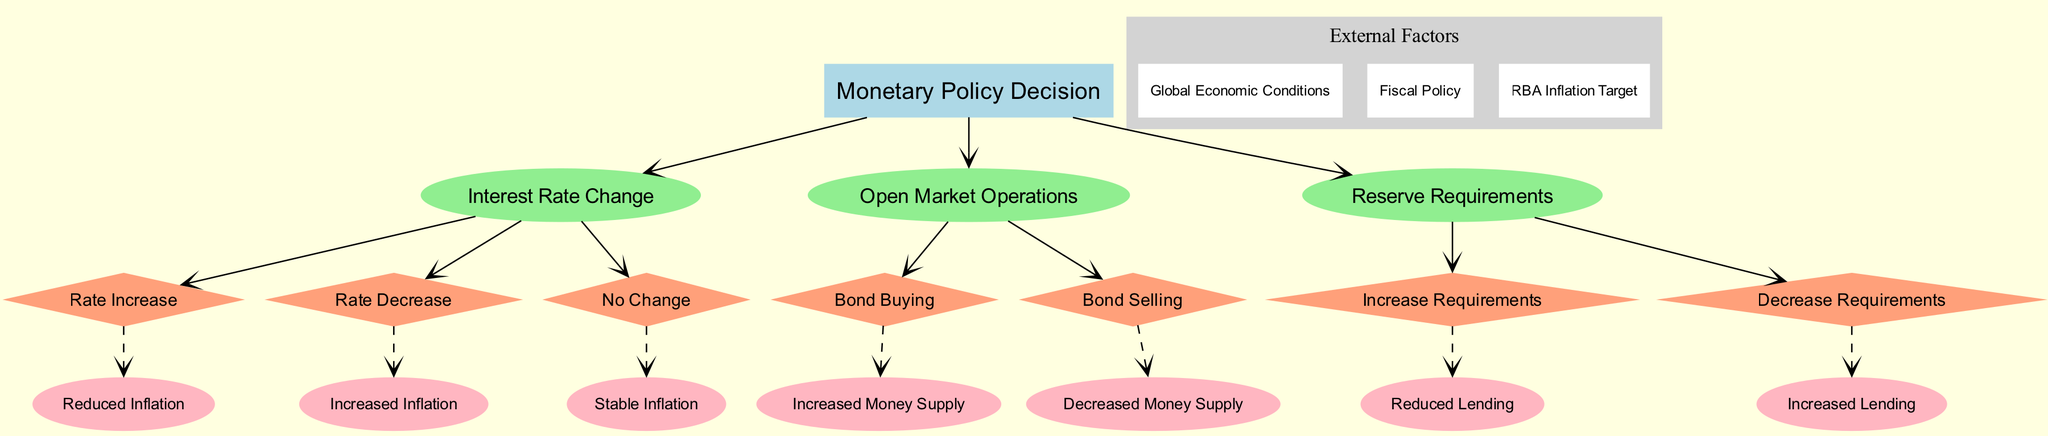What is the root node of the diagram? The root node is labeled "Monetary Policy Decision", which is the starting point of the decision tree and represents the overall focus of the analysis in the context of monetary policy and its impact on inflation.
Answer: Monetary Policy Decision How many branches are there from the root node? There are three branches stemming from the root node: "Interest Rate Change", "Open Market Operations", and "Reserve Requirements". This can be counted directly from the diagram structure.
Answer: 3 What outcome corresponds to a rate increase in the interest rate change branch? Following the path from the "Rate Increase" node in the "Interest Rate Change" branch, the outcome is "Reduced Inflation", indicating the expected result of this decision in the decision tree.
Answer: Reduced Inflation What happens if there is no change in interest rates? The path from the "No Change" node in the "Interest Rate Change" branch leads to the outcome "Stable Inflation", meaning that maintaining the current interest rate is expected to keep inflation stable.
Answer: Stable Inflation Which external factor is included in the diagram? The external factors mentioned include "Global Economic Conditions", "Fiscal Policy", and "RBA Inflation Target". Any one of these could be selected as an answer based on their inclusion under the external factors section.
Answer: Global Economic Conditions What is the outcome if reserve requirements are decreased? If we follow the path from the "Decrease Requirements" node in the "Reserve Requirements" branch, the corresponding outcome is "Increased Lending", signifying that lowering reserve requirements typically results in more borrowing by banks.
Answer: Increased Lending What is the overall relationship between open market operations and money supply? The open market operations branch indicates two possibilities: "Bond Buying" leads to "Increased Money Supply" and "Bond Selling" leads to "Decreased Money Supply", showing a direct relationship between these operations and the resultant money supply.
Answer: Increased Money Supply What is the outcome of bond selling in the open market operations branch? From the "Bond Selling" node in the "Open Market Operations" branch, the outcome is "Decreased Money Supply", representing the effect of this policy on the liquidity in the economy.
Answer: Decreased Money Supply If monetary policy involves bond buying, what will be the effect on the money supply? By following the edge from "Bond Buying" in the "Open Market Operations" branch, the outcome indicates "Increased Money Supply", clearly demonstrating the intended expansionary impact of this policy.
Answer: Increased Money Supply 